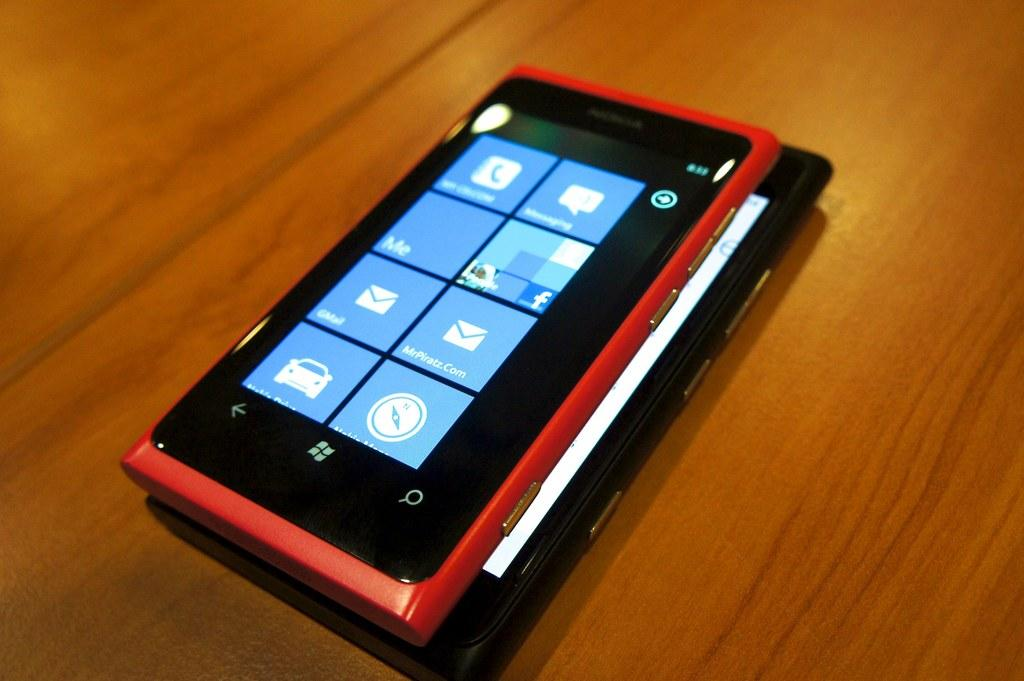<image>
Give a short and clear explanation of the subsequent image. a phone open to the home screen including the phone and messenging apps 